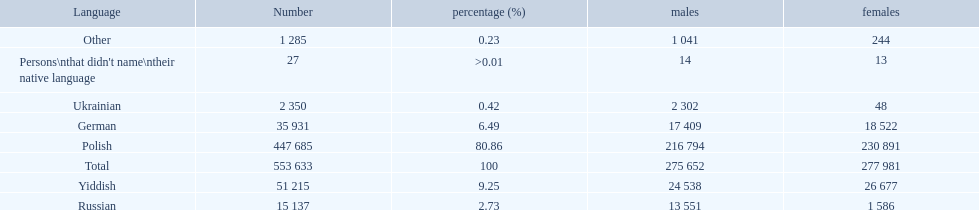Could you parse the entire table as a dict? {'header': ['Language', 'Number', 'percentage (%)', 'males', 'females'], 'rows': [['Other', '1 285', '0.23', '1 041', '244'], ["Persons\\nthat didn't name\\ntheir native language", '27', '>0.01', '14', '13'], ['Ukrainian', '2 350', '0.42', '2 302', '48'], ['German', '35 931', '6.49', '17 409', '18 522'], ['Polish', '447 685', '80.86', '216 794', '230 891'], ['Total', '553 633', '100', '275 652', '277 981'], ['Yiddish', '51 215', '9.25', '24 538', '26 677'], ['Russian', '15 137', '2.73', '13 551', '1 586']]} How many male and female german speakers are there? 35931. 